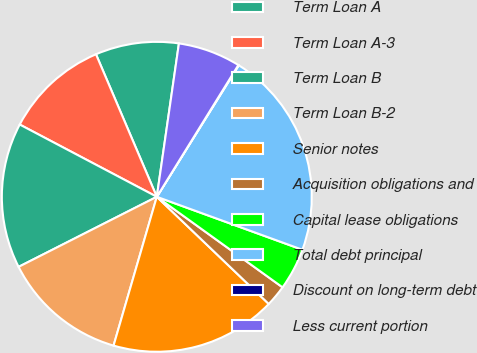Convert chart. <chart><loc_0><loc_0><loc_500><loc_500><pie_chart><fcel>Term Loan A<fcel>Term Loan A-3<fcel>Term Loan B<fcel>Term Loan B-2<fcel>Senior notes<fcel>Acquisition obligations and<fcel>Capital lease obligations<fcel>Total debt principal<fcel>Discount on long-term debt<fcel>Less current portion<nl><fcel>8.7%<fcel>10.86%<fcel>15.19%<fcel>13.03%<fcel>17.35%<fcel>2.22%<fcel>4.38%<fcel>21.68%<fcel>0.05%<fcel>6.54%<nl></chart> 